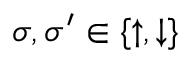Convert formula to latex. <formula><loc_0><loc_0><loc_500><loc_500>\sigma , \sigma ^ { \prime } \in \{ \uparrow , \downarrow \}</formula> 